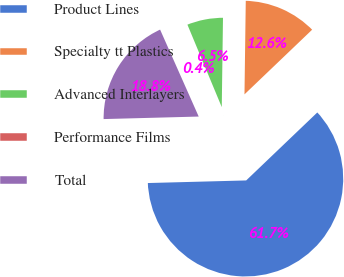Convert chart to OTSL. <chart><loc_0><loc_0><loc_500><loc_500><pie_chart><fcel>Product Lines<fcel>Specialty tt Plastics<fcel>Advanced Interlayers<fcel>Performance Films<fcel>Total<nl><fcel>61.72%<fcel>12.64%<fcel>6.5%<fcel>0.37%<fcel>18.77%<nl></chart> 